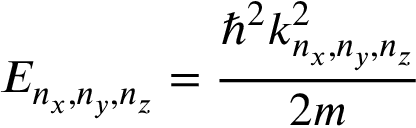Convert formula to latex. <formula><loc_0><loc_0><loc_500><loc_500>E _ { n _ { x } , n _ { y } , n _ { z } } = { \frac { \hbar { ^ } { 2 } k _ { n _ { x } , n _ { y } , n _ { z } } ^ { 2 } } { 2 m } }</formula> 